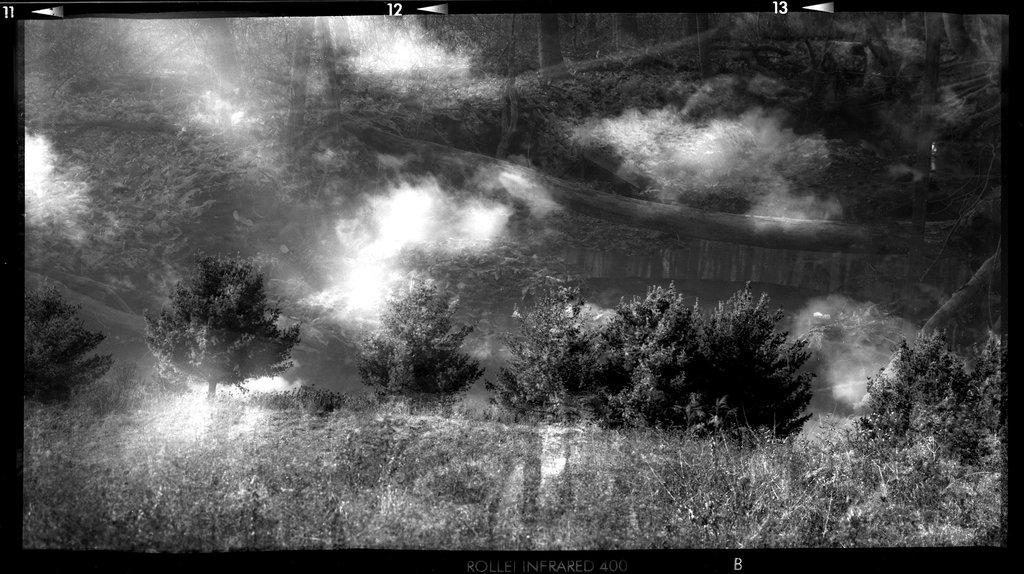What type of vegetation can be seen in the background of the image? There are trees in the background of the image. What is the ground surface like where the trees are located? The trees are on a grassland. What is visible in the sky in the image? Clouds are present in the sky. What is the color scheme of the image? The image is black and white. What type of leather can be seen growing on the trees in the image? There is no leather present on the trees in the image, as trees typically grow leaves, not leather. How many people are visible in the image? There is no group of people present in the image; it features trees, grassland, and a sky with clouds. 